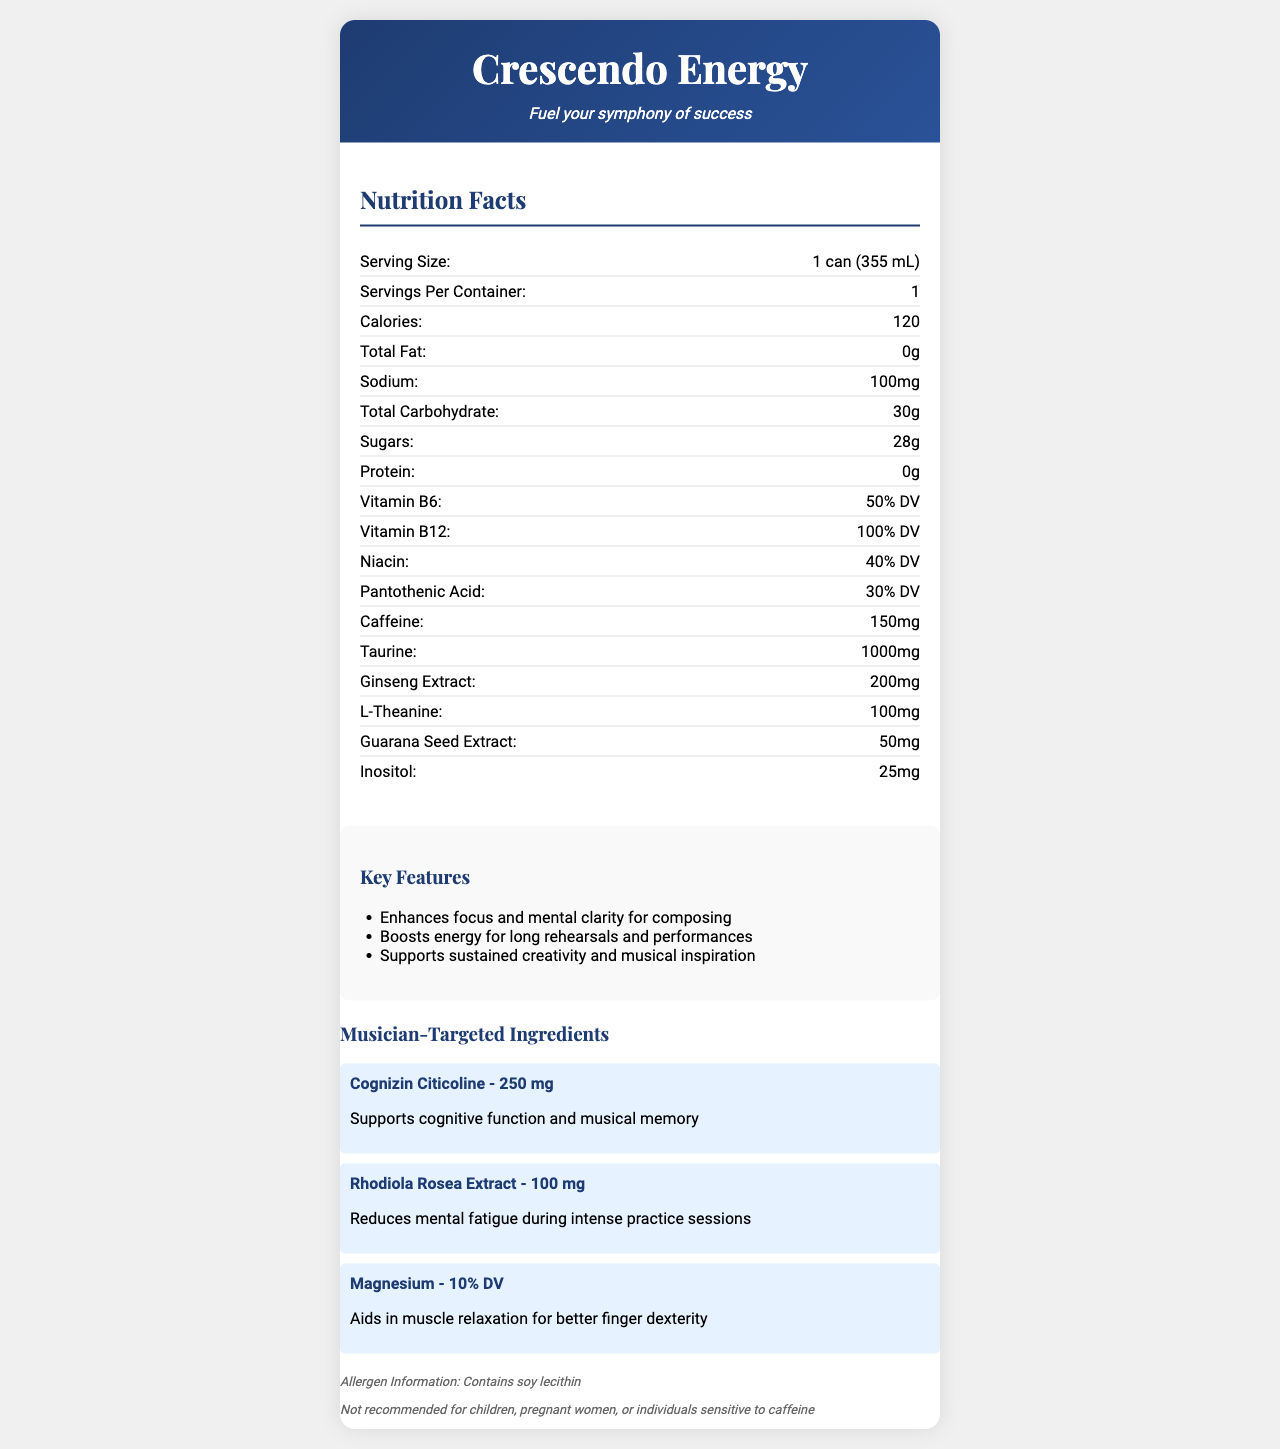what is the serving size? The document states that the serving size is 1 can (355 mL).
Answer: 1 can (355 mL) how many calories are in one serving of Crescendo Energy? The document lists the calories per serving as 120.
Answer: 120 how much caffeine is in one can of Crescendo Energy? The document indicates that one can contains 150 mg of caffeine.
Answer: 150 mg which ingredient supports cognitive function and musical memory? The document mentions that Cognizin Citicoline supports cognitive function and musical memory.
Answer: Cognizin Citicoline what is the amount of vitamin B12 provided in one serving, and what percentage of the daily value does it represent? The document states that one serving contains Vitamin B12 amounting to 100% of the daily value.
Answer: 100% DV how many grams of total carbohydrate are in one serving? The document lists the total carbohydrate content as 30 grams per serving.
Answer: 30 g what is the tagline mentioned for Crescendo Energy? The tagline mentioned in the document is "Fuel your symphony of success".
Answer: Fuel your symphony of success what is the main allergen information provided for Crescendo Energy? A. Contains peanuts B. Contains soy lecithin C. Gluten-free D. Dairy-free The document states that the allergen information provided is "Contains soy lecithin".
Answer: B which of the following is a listed key feature of Crescendo Energy? I. Enhances focus and mental clarity II. Reduces muscle soreness III. Boosts energy for long rehearsals IV. Contains zero calories The document lists "Enhances focus and mental clarity for composing" and "Boosts energy for long rehearsals and performances" as key features.
Answer: I, III is Crescendo Energy recommended for children? The document includes a disclaimer stating that the product is not recommended for children.
Answer: No what is one of the musician-targeted ingredients in Crescendo Energy and its benefit? The document lists Rhodiola Rosea Extract as one of the musician-targeted ingredients and states that it reduces mental fatigue during intense practice sessions.
Answer: Rhodiola Rosea Extract, reduces mental fatigue during intense practice sessions summarize the main features and target audience of Crescendo Energy. Crescendo Energy is promoted as an energy drink with specialized benefits for musicians, including focus enhancement and energy boosting. It contains notable ingredients that support cognitive function and reduce mental fatigue. Its nutritional content includes vitamins, caffeine, and specific musician-targeted ingredients. The product is marketed with a clear focus on aiding musical performance and creativity, while also extending cautions regarding its consumption by certain groups.
Answer: Crescendo Energy is an energy drink designed specifically for musicians and composers, aiming to enhance focus, boost energy, and support creativity. It contains various nutrients and ingredients such as vitamins, caffeine, taurine, and specific cognitive enhancers like Cognizin Citicoline and Rhodiola Rosea Extract. The drink also highlights its benefits for mental clarity and musical inspiration while providing essential nutrition without allergens like gluten or dairy, but it does contain soy lecithin. It is not recommended for children or those sensitive to caffeine. what is the exact amount of taurine in Crescendo Energy? The document specifies that one can of Crescendo Energy contains 1000 mg of taurine.
Answer: 1000 mg how much sodium does one serving of Crescendo Energy contain? The document lists the sodium content as 100 mg per serving.
Answer: 100 mg does Crescendo Energy use real fruit juices? The document does not provide any information about whether Crescendo Energy uses real fruit juices.
Answer: Cannot be determined 